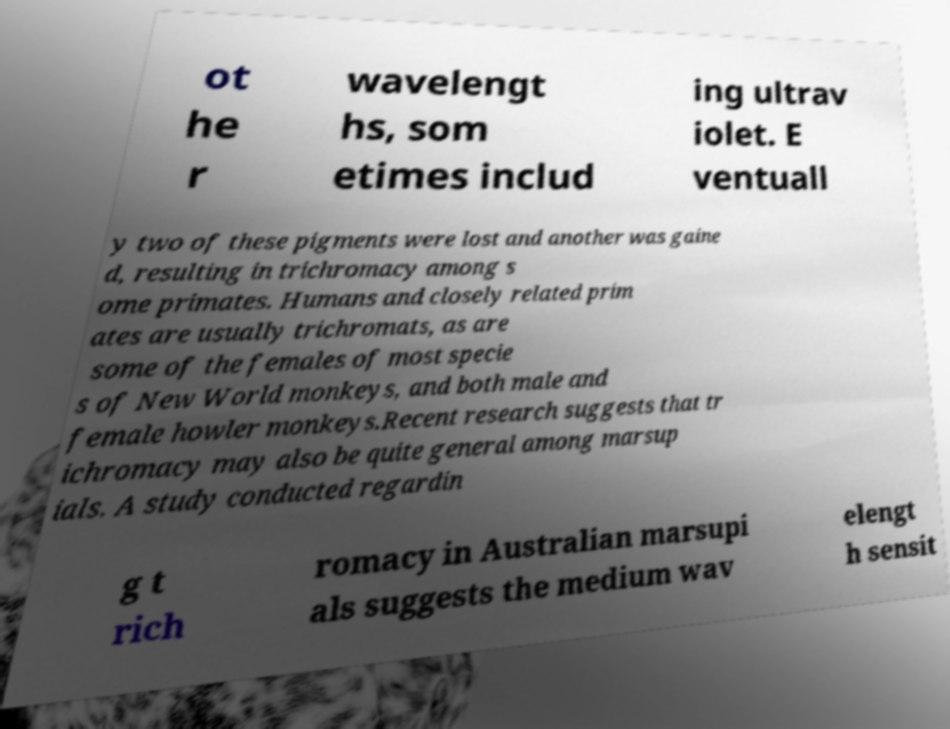There's text embedded in this image that I need extracted. Can you transcribe it verbatim? ot he r wavelengt hs, som etimes includ ing ultrav iolet. E ventuall y two of these pigments were lost and another was gaine d, resulting in trichromacy among s ome primates. Humans and closely related prim ates are usually trichromats, as are some of the females of most specie s of New World monkeys, and both male and female howler monkeys.Recent research suggests that tr ichromacy may also be quite general among marsup ials. A study conducted regardin g t rich romacy in Australian marsupi als suggests the medium wav elengt h sensit 